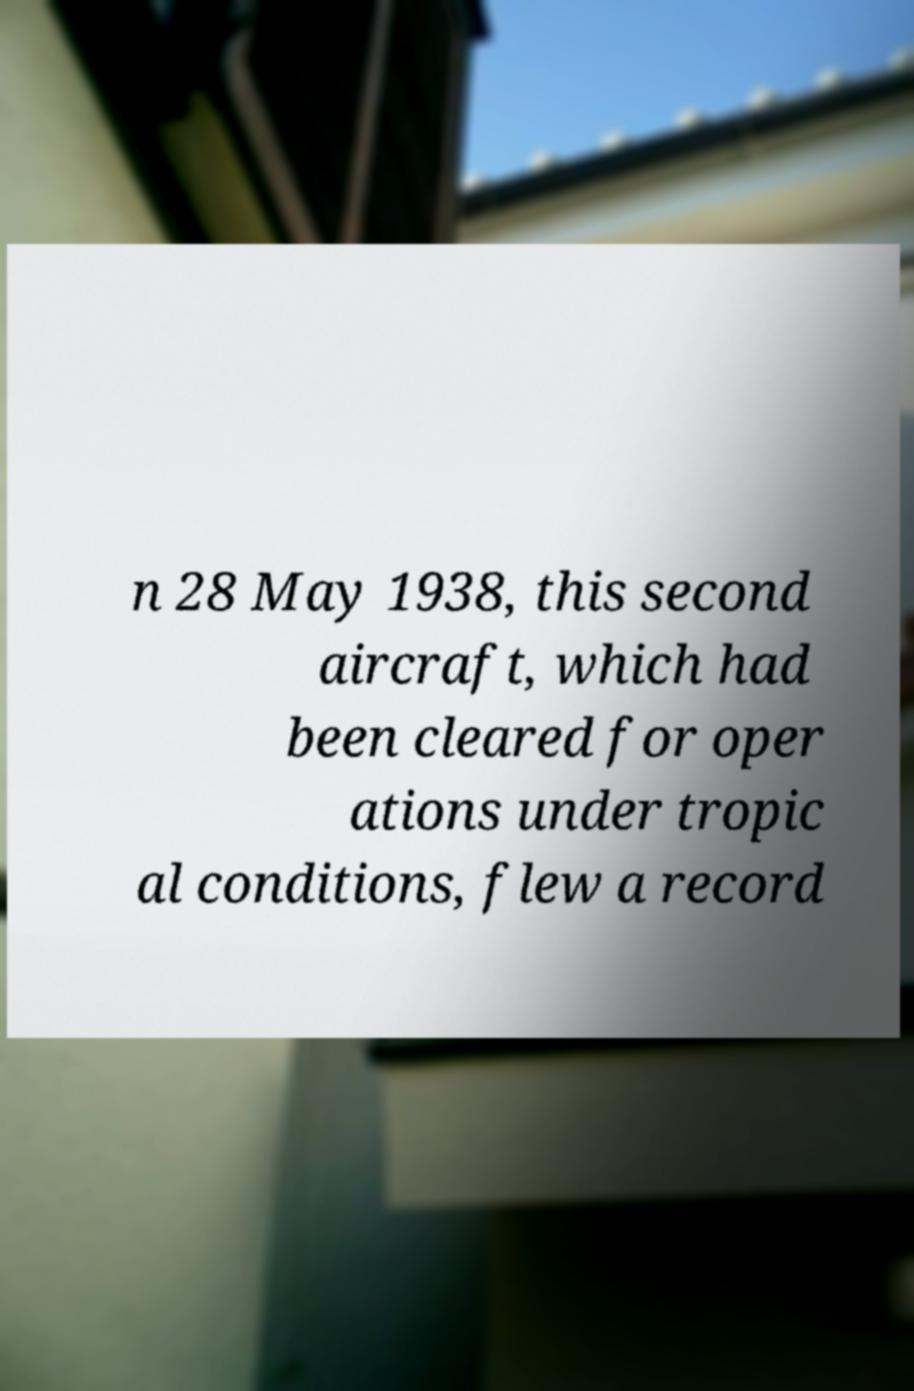Could you assist in decoding the text presented in this image and type it out clearly? n 28 May 1938, this second aircraft, which had been cleared for oper ations under tropic al conditions, flew a record 